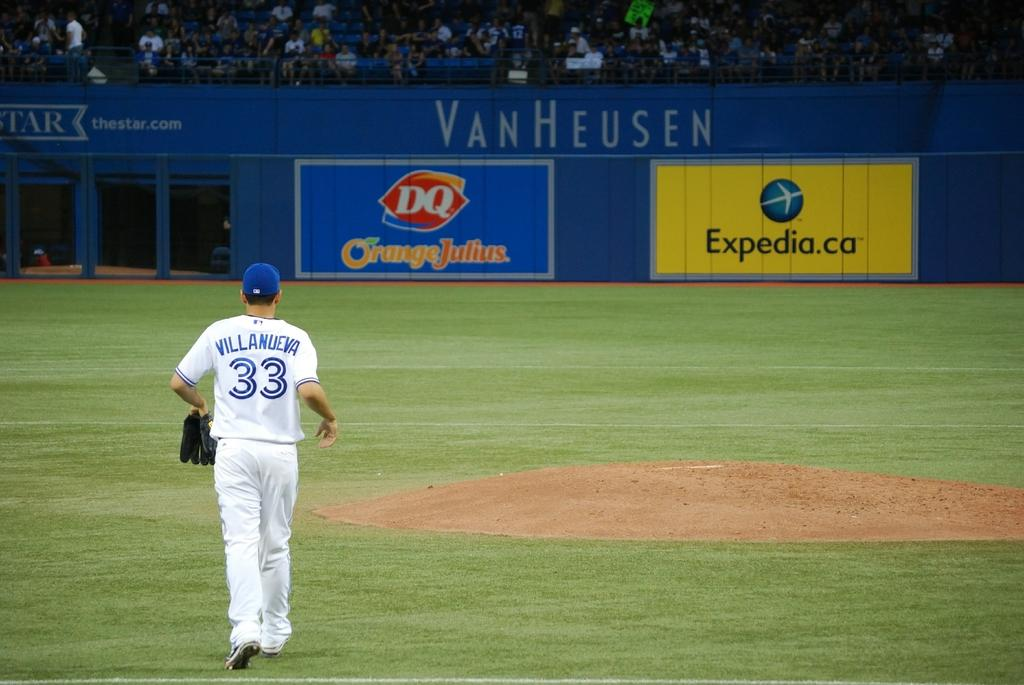Provide a one-sentence caption for the provided image. Baseball player Villanueva is walking on a field that has a VanHeusen banner on it. 